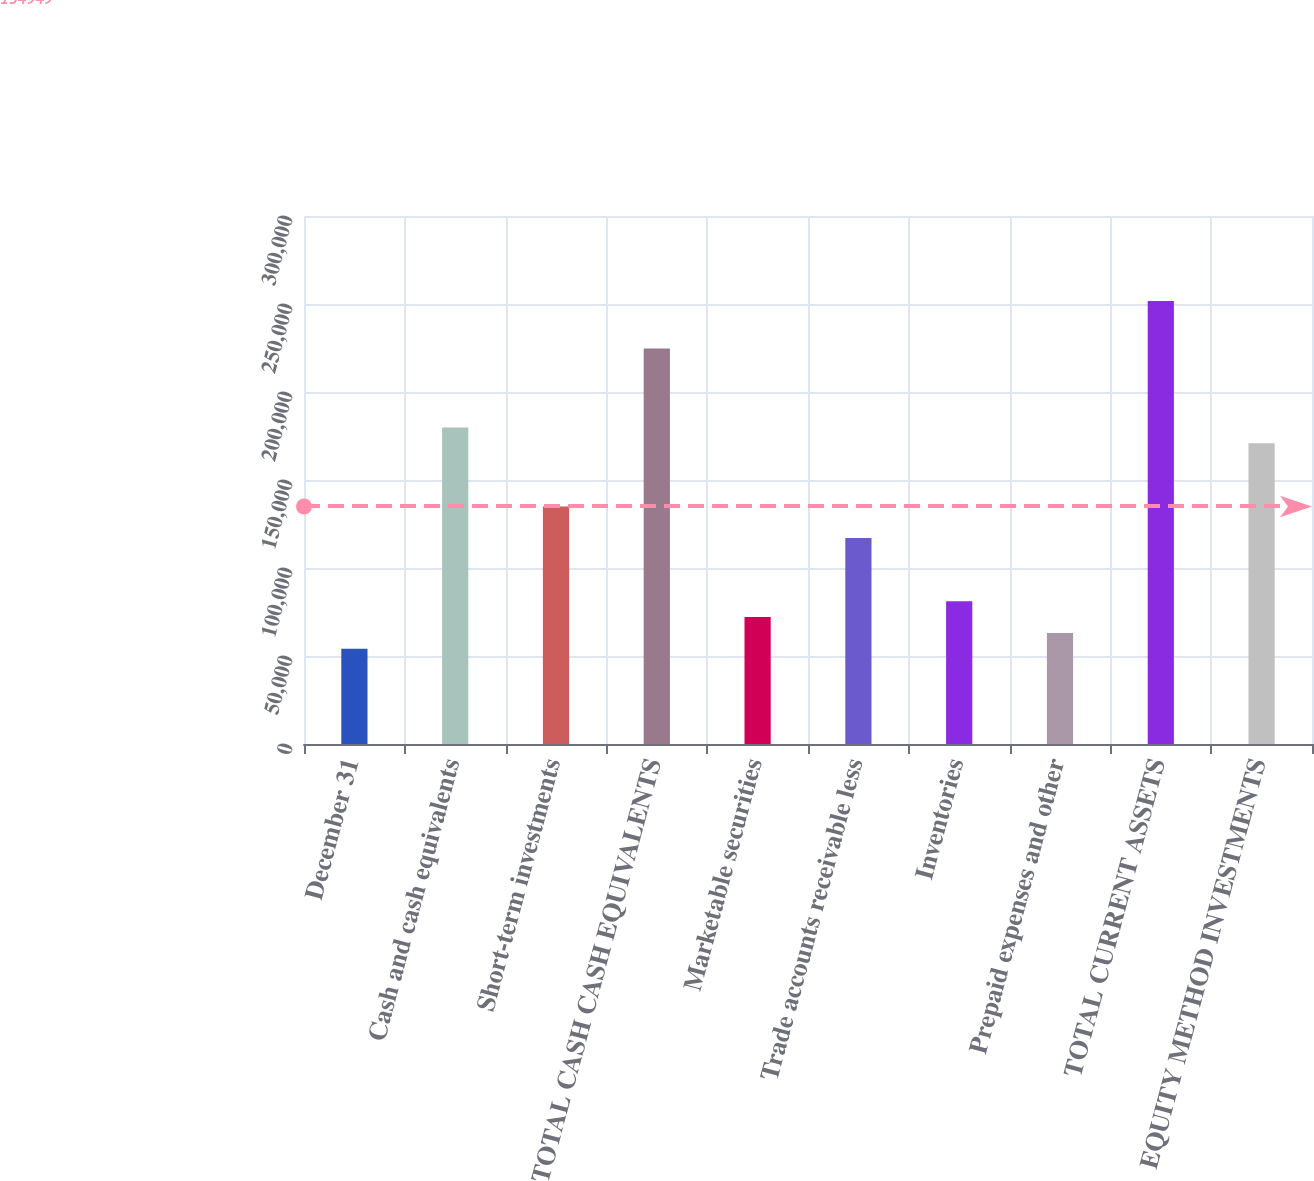Convert chart to OTSL. <chart><loc_0><loc_0><loc_500><loc_500><bar_chart><fcel>December 31<fcel>Cash and cash equivalents<fcel>Short-term investments<fcel>TOTAL CASH CASH EQUIVALENTS<fcel>Marketable securities<fcel>Trade accounts receivable less<fcel>Inventories<fcel>Prepaid expenses and other<fcel>TOTAL CURRENT ASSETS<fcel>EQUITY METHOD INVESTMENTS<nl><fcel>54139.8<fcel>179843<fcel>134949<fcel>224737<fcel>72097.4<fcel>116991<fcel>81076.2<fcel>63118.6<fcel>251673<fcel>170864<nl></chart> 